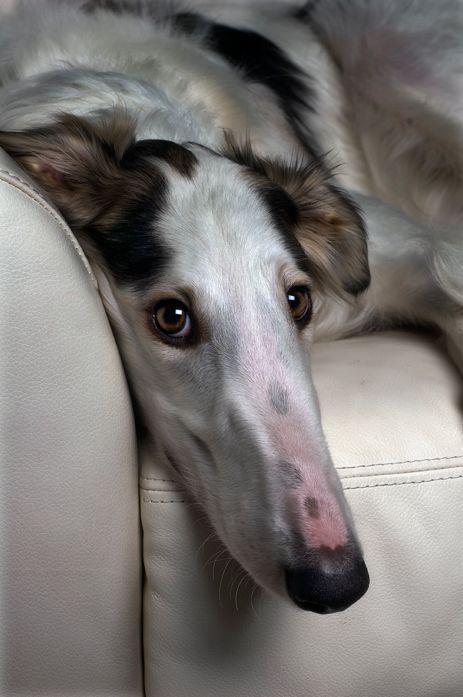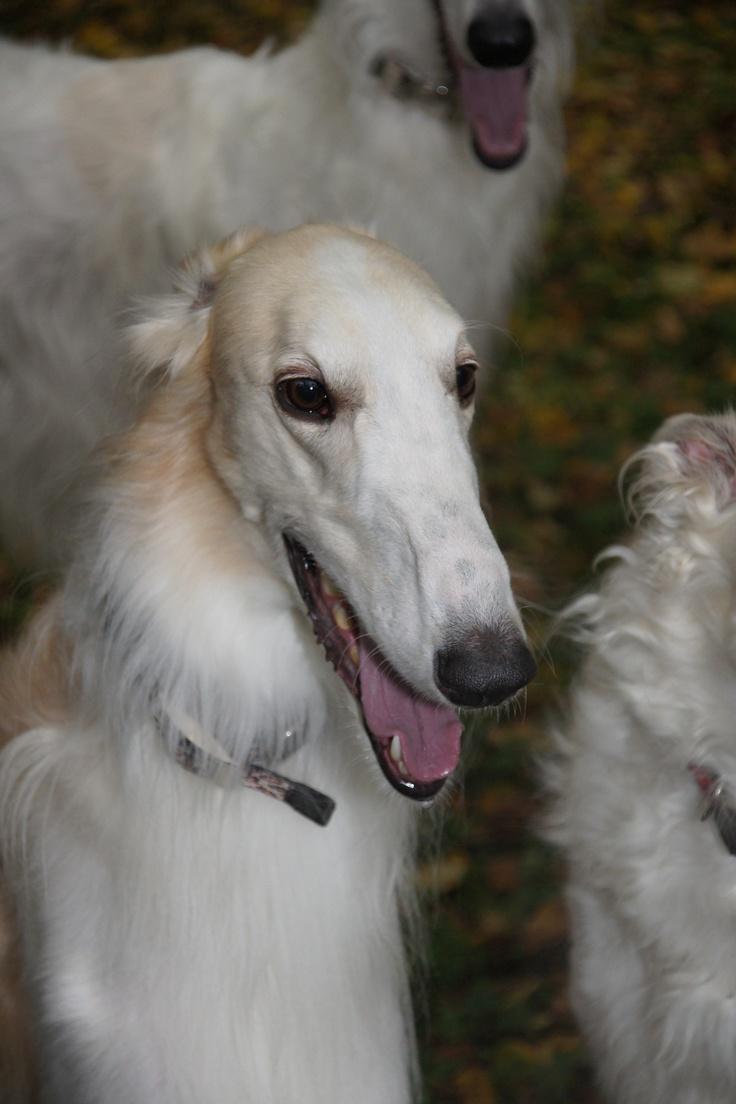The first image is the image on the left, the second image is the image on the right. Assess this claim about the two images: "An image shows one hound standing still with its body in profile and tail hanging down.". Correct or not? Answer yes or no. No. 